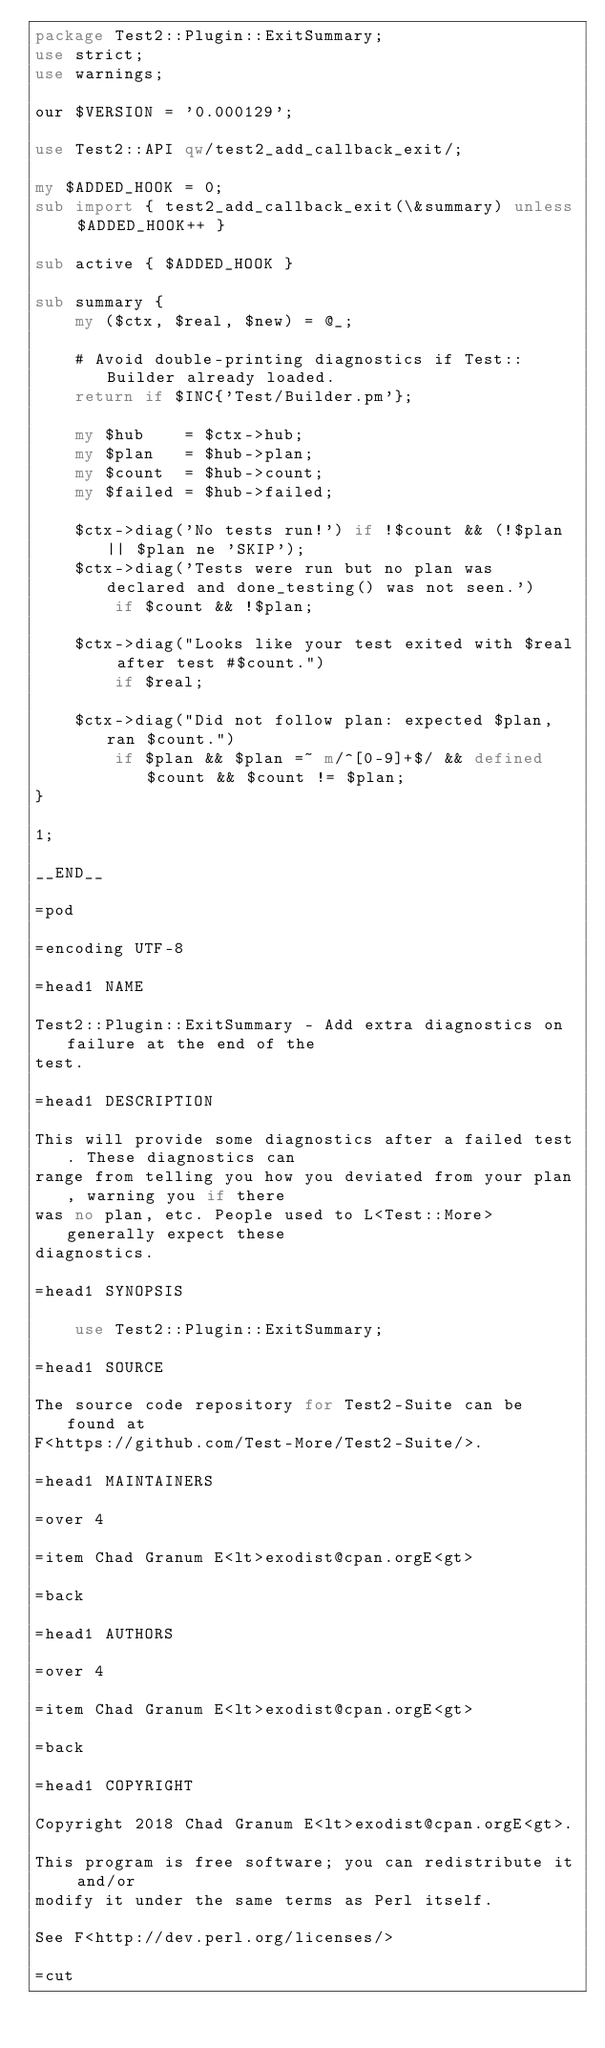<code> <loc_0><loc_0><loc_500><loc_500><_Perl_>package Test2::Plugin::ExitSummary;
use strict;
use warnings;

our $VERSION = '0.000129';

use Test2::API qw/test2_add_callback_exit/;

my $ADDED_HOOK = 0;
sub import { test2_add_callback_exit(\&summary) unless $ADDED_HOOK++ }

sub active { $ADDED_HOOK }

sub summary {
    my ($ctx, $real, $new) = @_;

    # Avoid double-printing diagnostics if Test::Builder already loaded.
    return if $INC{'Test/Builder.pm'};

    my $hub    = $ctx->hub;
    my $plan   = $hub->plan;
    my $count  = $hub->count;
    my $failed = $hub->failed;

    $ctx->diag('No tests run!') if !$count && (!$plan || $plan ne 'SKIP');
    $ctx->diag('Tests were run but no plan was declared and done_testing() was not seen.')
        if $count && !$plan;

    $ctx->diag("Looks like your test exited with $real after test #$count.")
        if $real;

    $ctx->diag("Did not follow plan: expected $plan, ran $count.")
        if $plan && $plan =~ m/^[0-9]+$/ && defined $count && $count != $plan;
}

1;

__END__

=pod

=encoding UTF-8

=head1 NAME

Test2::Plugin::ExitSummary - Add extra diagnostics on failure at the end of the
test.

=head1 DESCRIPTION

This will provide some diagnostics after a failed test. These diagnostics can
range from telling you how you deviated from your plan, warning you if there
was no plan, etc. People used to L<Test::More> generally expect these
diagnostics.

=head1 SYNOPSIS

    use Test2::Plugin::ExitSummary;

=head1 SOURCE

The source code repository for Test2-Suite can be found at
F<https://github.com/Test-More/Test2-Suite/>.

=head1 MAINTAINERS

=over 4

=item Chad Granum E<lt>exodist@cpan.orgE<gt>

=back

=head1 AUTHORS

=over 4

=item Chad Granum E<lt>exodist@cpan.orgE<gt>

=back

=head1 COPYRIGHT

Copyright 2018 Chad Granum E<lt>exodist@cpan.orgE<gt>.

This program is free software; you can redistribute it and/or
modify it under the same terms as Perl itself.

See F<http://dev.perl.org/licenses/>

=cut
</code> 